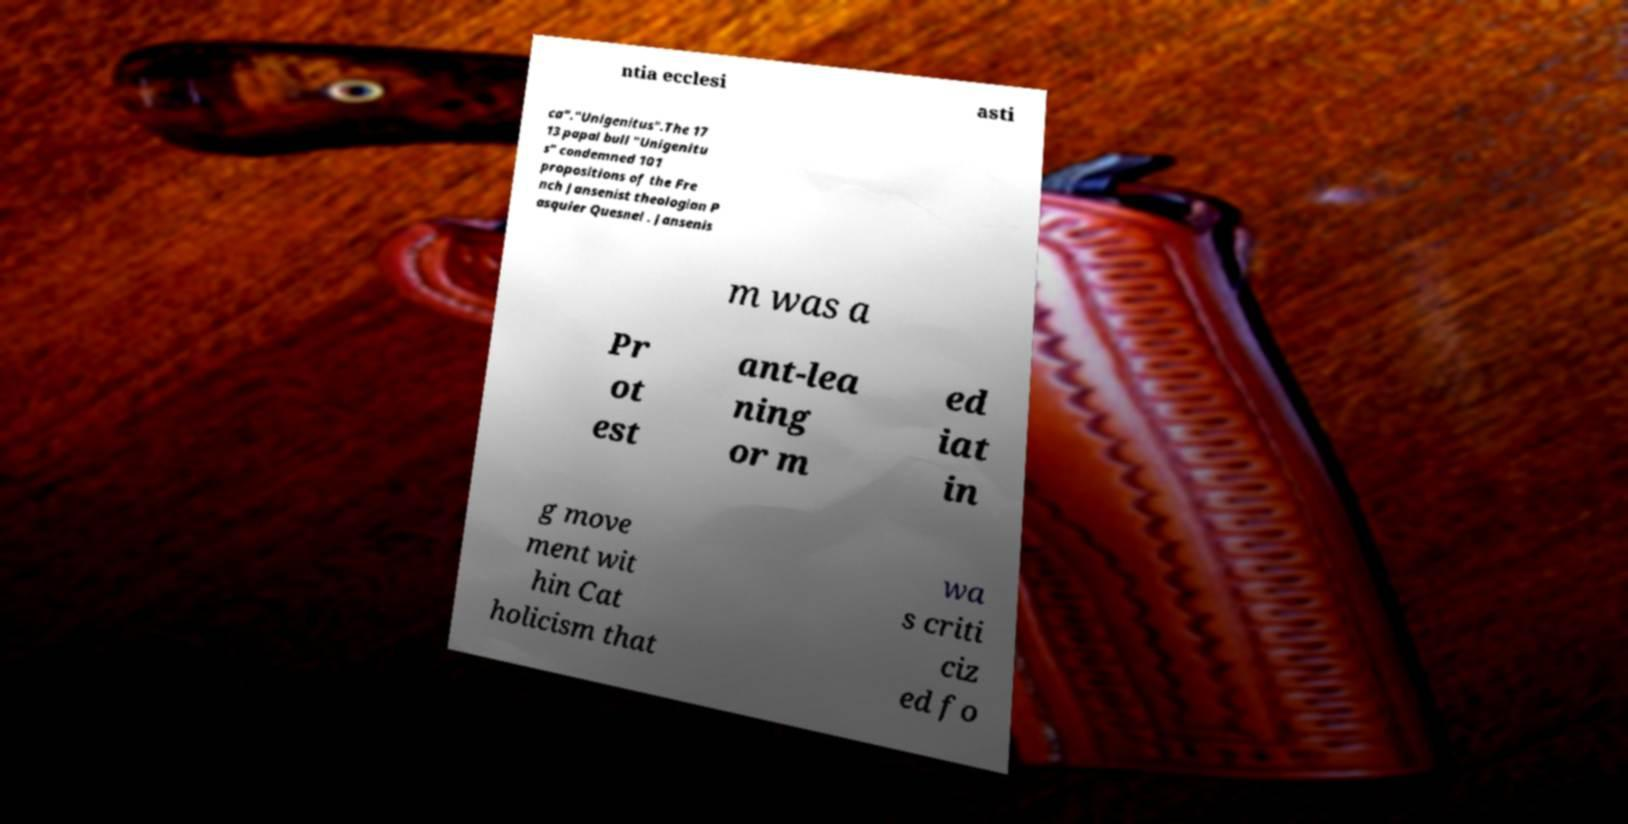For documentation purposes, I need the text within this image transcribed. Could you provide that? ntia ecclesi asti ca"."Unigenitus".The 17 13 papal bull "Unigenitu s" condemned 101 propositions of the Fre nch Jansenist theologian P asquier Quesnel . Jansenis m was a Pr ot est ant-lea ning or m ed iat in g move ment wit hin Cat holicism that wa s criti ciz ed fo 